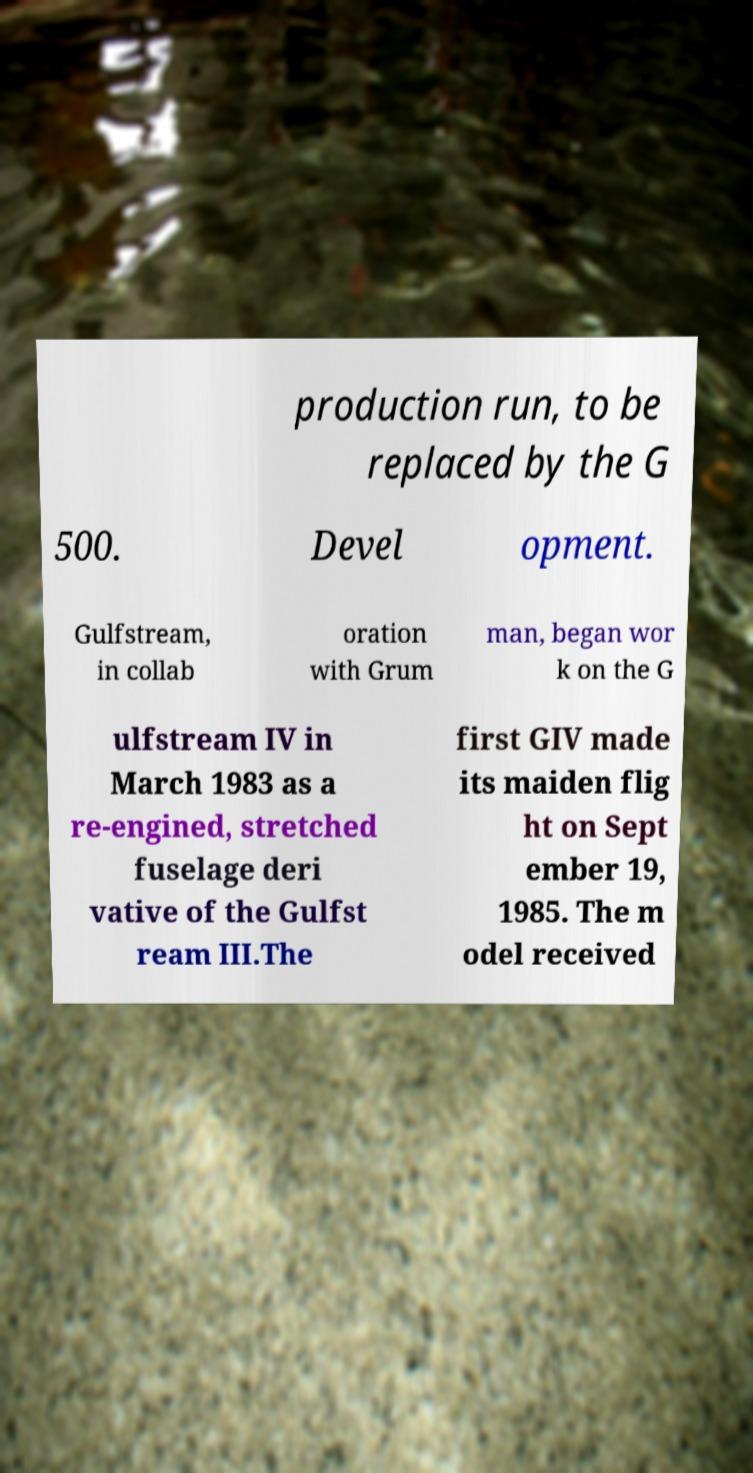Please identify and transcribe the text found in this image. production run, to be replaced by the G 500. Devel opment. Gulfstream, in collab oration with Grum man, began wor k on the G ulfstream IV in March 1983 as a re-engined, stretched fuselage deri vative of the Gulfst ream III.The first GIV made its maiden flig ht on Sept ember 19, 1985. The m odel received 